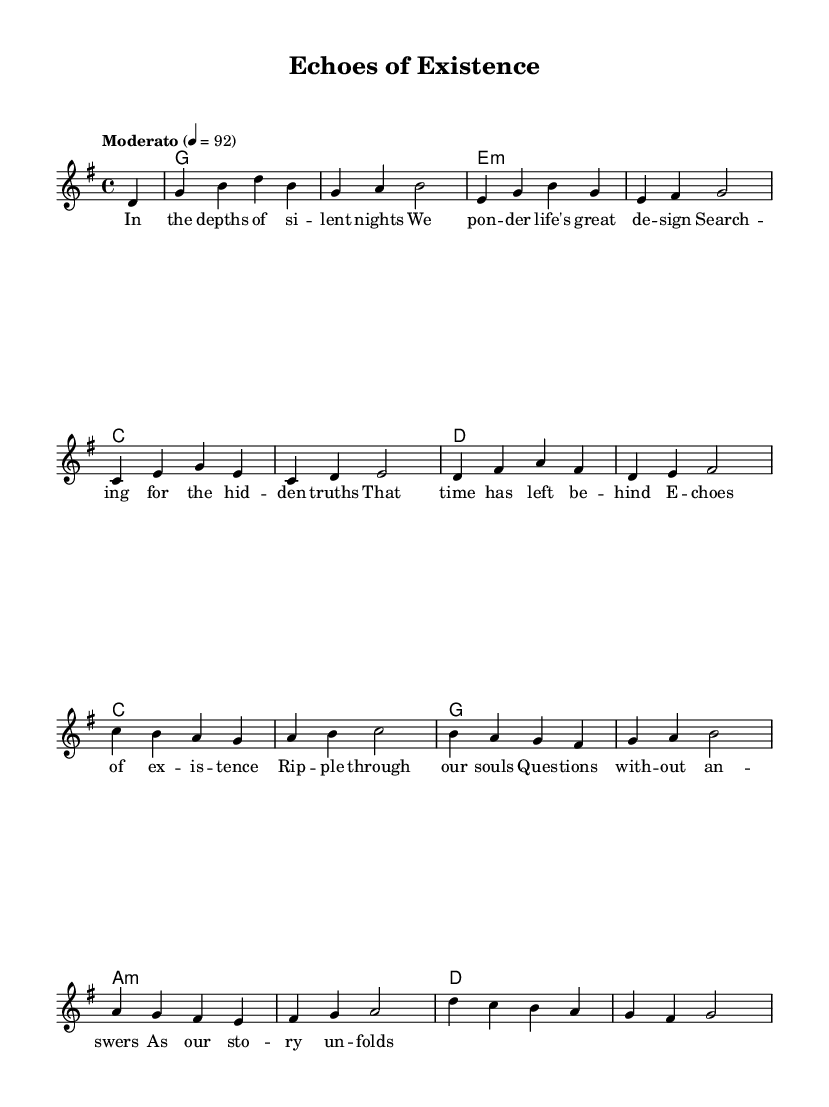What is the key signature of this music? The key signature is G major, which has one sharp (F#). This can be identified by looking at the beginning of the staff where the sharps are indicated.
Answer: G major What is the time signature of this piece? The time signature is 4/4, which indicates that there are four beats per measure and a quarter note receives one beat. This can be found at the beginning of the staff as well.
Answer: 4/4 What is the tempo marking for this piece? The tempo marking is "Moderato," which indicates a moderate speed. This can be seen at the start of the music where tempo indications are typically written.
Answer: Moderato How many measures are in the melody section? There are 12 measures in the melody section. This is counted by following the measure lines in the sheet music.
Answer: 12 What are the first two words of the lyrics? The first two words of the lyrics are "In the." This can be directly observed at the beginning of the lyrics below the staff.
Answer: In the Which chord is played in the second measure? The chord played in the second measure is G major. This can be determined by examining the chord symbols above the staff at the corresponding measure.
Answer: G What philosophical theme is explored in the lyrics? The philosophical theme explored in the lyrics is the search for hidden truths. This can be inferred from the lines discussing pondering life's design and seeking truths left behind.
Answer: Hidden truths 